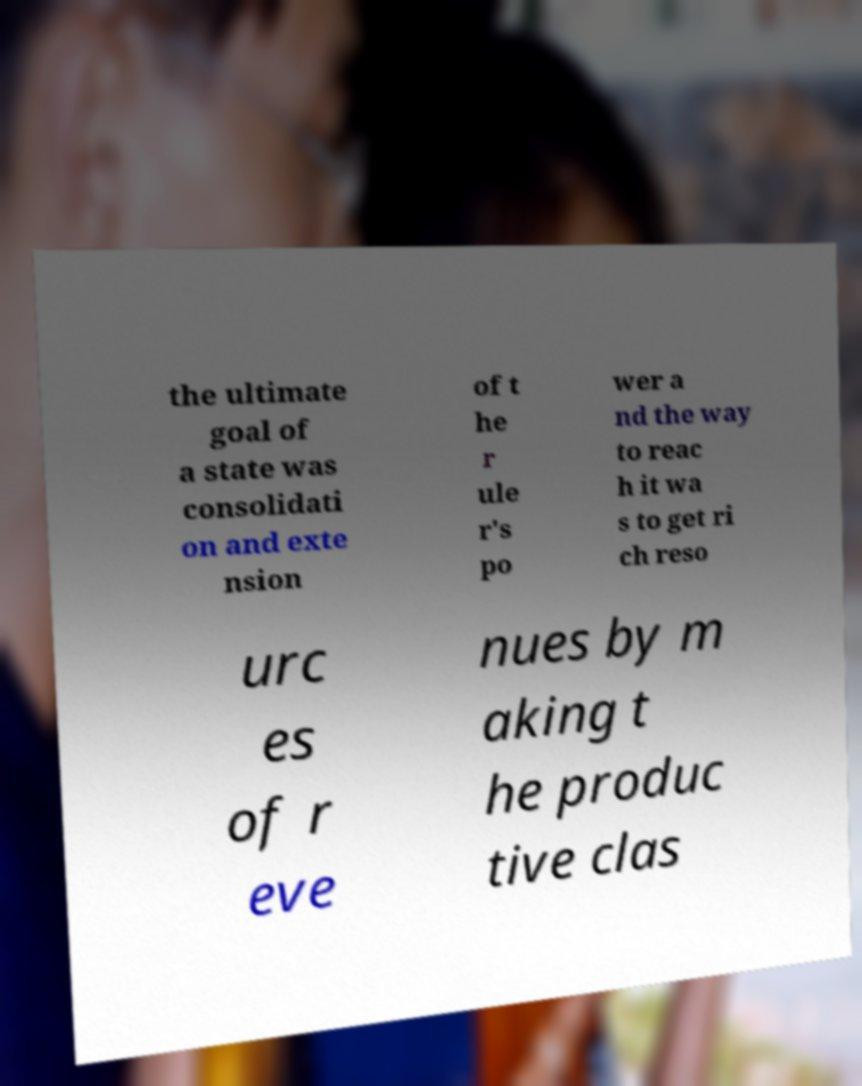I need the written content from this picture converted into text. Can you do that? the ultimate goal of a state was consolidati on and exte nsion of t he r ule r's po wer a nd the way to reac h it wa s to get ri ch reso urc es of r eve nues by m aking t he produc tive clas 